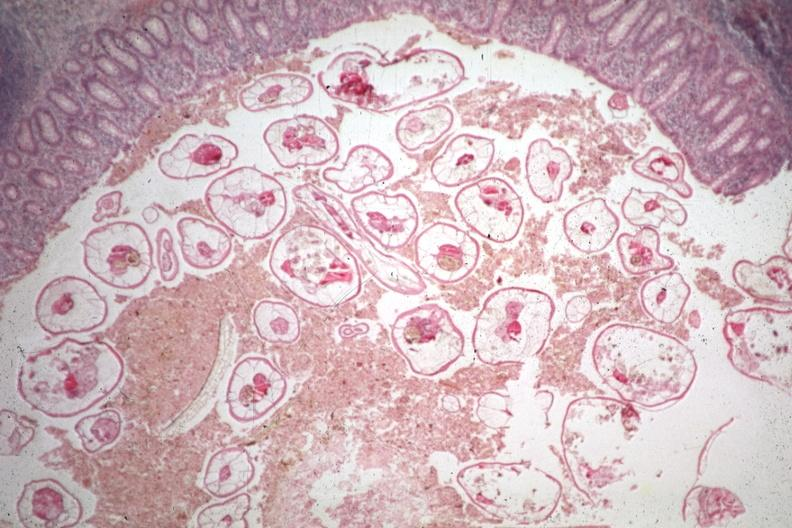s carcinoma metastatic lung present?
Answer the question using a single word or phrase. No 